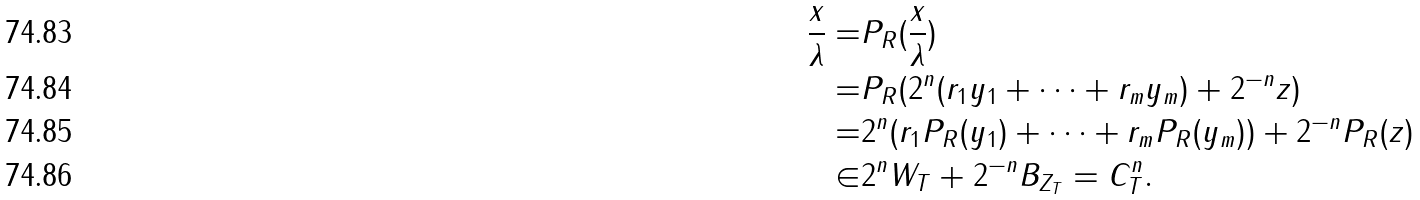Convert formula to latex. <formula><loc_0><loc_0><loc_500><loc_500>\frac { x } { \lambda } = & P _ { R } ( \frac { x } { \lambda } ) \\ = & P _ { R } ( 2 ^ { n } ( r _ { 1 } y _ { 1 } + \dots + r _ { m } y _ { m } ) + 2 ^ { - n } z ) \\ = & 2 ^ { n } ( r _ { 1 } P _ { R } ( y _ { 1 } ) + \dots + r _ { m } P _ { R } ( y _ { m } ) ) + 2 ^ { - n } P _ { R } ( z ) \\ \in & 2 ^ { n } W _ { T } + 2 ^ { - n } B _ { Z _ { T } } = C ^ { n } _ { T } .</formula> 